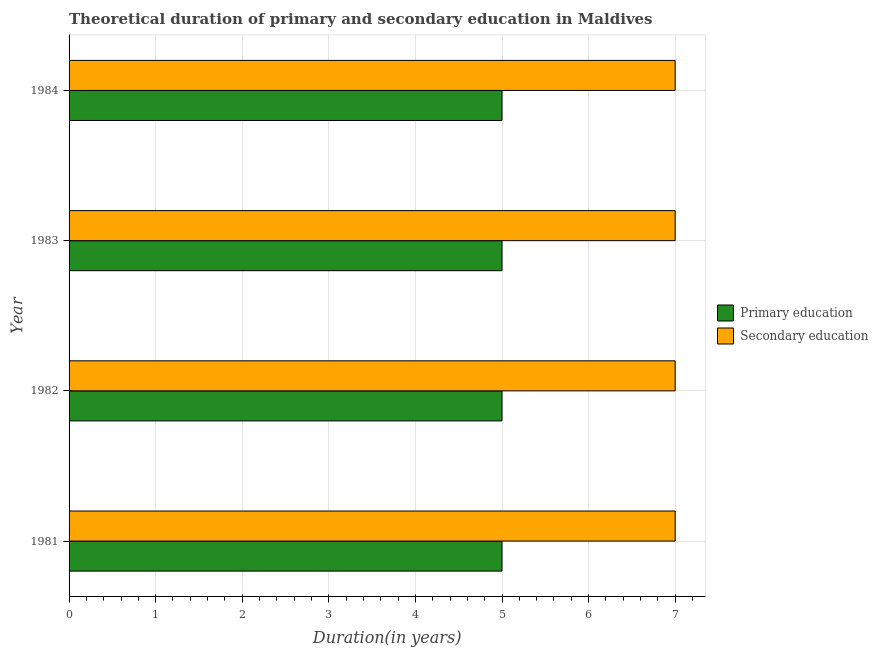How many different coloured bars are there?
Provide a succinct answer. 2. Are the number of bars per tick equal to the number of legend labels?
Offer a terse response. Yes. How many bars are there on the 1st tick from the top?
Offer a very short reply. 2. How many bars are there on the 4th tick from the bottom?
Your response must be concise. 2. What is the label of the 3rd group of bars from the top?
Offer a terse response. 1982. What is the duration of secondary education in 1981?
Keep it short and to the point. 7. Across all years, what is the maximum duration of secondary education?
Your response must be concise. 7. Across all years, what is the minimum duration of primary education?
Your answer should be compact. 5. In which year was the duration of secondary education minimum?
Offer a very short reply. 1981. What is the total duration of secondary education in the graph?
Keep it short and to the point. 28. What is the difference between the duration of secondary education in 1981 and that in 1984?
Your answer should be very brief. 0. What is the difference between the duration of primary education in 1984 and the duration of secondary education in 1983?
Keep it short and to the point. -2. In the year 1981, what is the difference between the duration of primary education and duration of secondary education?
Your response must be concise. -2. What is the ratio of the duration of primary education in 1981 to that in 1982?
Provide a succinct answer. 1. What is the difference between the highest and the lowest duration of secondary education?
Offer a terse response. 0. In how many years, is the duration of primary education greater than the average duration of primary education taken over all years?
Your response must be concise. 0. Is the sum of the duration of secondary education in 1982 and 1983 greater than the maximum duration of primary education across all years?
Your response must be concise. Yes. What does the 2nd bar from the top in 1983 represents?
Your response must be concise. Primary education. What does the 2nd bar from the bottom in 1983 represents?
Give a very brief answer. Secondary education. How many bars are there?
Ensure brevity in your answer.  8. Are all the bars in the graph horizontal?
Ensure brevity in your answer.  Yes. What is the difference between two consecutive major ticks on the X-axis?
Ensure brevity in your answer.  1. Are the values on the major ticks of X-axis written in scientific E-notation?
Ensure brevity in your answer.  No. Does the graph contain any zero values?
Your answer should be very brief. No. Does the graph contain grids?
Your answer should be compact. Yes. How many legend labels are there?
Provide a short and direct response. 2. What is the title of the graph?
Provide a short and direct response. Theoretical duration of primary and secondary education in Maldives. Does "Exports of goods" appear as one of the legend labels in the graph?
Your response must be concise. No. What is the label or title of the X-axis?
Make the answer very short. Duration(in years). What is the label or title of the Y-axis?
Keep it short and to the point. Year. What is the Duration(in years) in Primary education in 1981?
Provide a short and direct response. 5. What is the Duration(in years) in Secondary education in 1981?
Provide a succinct answer. 7. What is the Duration(in years) in Primary education in 1982?
Provide a succinct answer. 5. What is the Duration(in years) in Primary education in 1983?
Give a very brief answer. 5. What is the Duration(in years) of Secondary education in 1984?
Your response must be concise. 7. What is the difference between the Duration(in years) of Secondary education in 1981 and that in 1982?
Offer a very short reply. 0. What is the difference between the Duration(in years) of Primary education in 1981 and that in 1983?
Your answer should be very brief. 0. What is the difference between the Duration(in years) in Secondary education in 1981 and that in 1984?
Provide a short and direct response. 0. What is the difference between the Duration(in years) in Secondary education in 1982 and that in 1984?
Provide a succinct answer. 0. What is the difference between the Duration(in years) of Secondary education in 1983 and that in 1984?
Provide a succinct answer. 0. What is the difference between the Duration(in years) in Primary education in 1981 and the Duration(in years) in Secondary education in 1982?
Provide a short and direct response. -2. What is the difference between the Duration(in years) in Primary education in 1981 and the Duration(in years) in Secondary education in 1984?
Provide a short and direct response. -2. What is the average Duration(in years) in Secondary education per year?
Give a very brief answer. 7. In the year 1983, what is the difference between the Duration(in years) in Primary education and Duration(in years) in Secondary education?
Ensure brevity in your answer.  -2. In the year 1984, what is the difference between the Duration(in years) of Primary education and Duration(in years) of Secondary education?
Ensure brevity in your answer.  -2. What is the ratio of the Duration(in years) in Primary education in 1981 to that in 1982?
Your answer should be compact. 1. What is the ratio of the Duration(in years) in Secondary education in 1981 to that in 1982?
Ensure brevity in your answer.  1. What is the ratio of the Duration(in years) of Primary education in 1981 to that in 1983?
Your response must be concise. 1. What is the ratio of the Duration(in years) in Primary education in 1981 to that in 1984?
Provide a succinct answer. 1. What is the ratio of the Duration(in years) of Secondary education in 1981 to that in 1984?
Keep it short and to the point. 1. What is the ratio of the Duration(in years) in Primary education in 1982 to that in 1983?
Ensure brevity in your answer.  1. What is the ratio of the Duration(in years) of Secondary education in 1982 to that in 1983?
Keep it short and to the point. 1. What is the ratio of the Duration(in years) in Primary education in 1982 to that in 1984?
Keep it short and to the point. 1. What is the ratio of the Duration(in years) of Secondary education in 1982 to that in 1984?
Provide a short and direct response. 1. What is the ratio of the Duration(in years) in Primary education in 1983 to that in 1984?
Ensure brevity in your answer.  1. What is the ratio of the Duration(in years) in Secondary education in 1983 to that in 1984?
Provide a short and direct response. 1. What is the difference between the highest and the second highest Duration(in years) of Secondary education?
Your response must be concise. 0. What is the difference between the highest and the lowest Duration(in years) in Primary education?
Give a very brief answer. 0. 